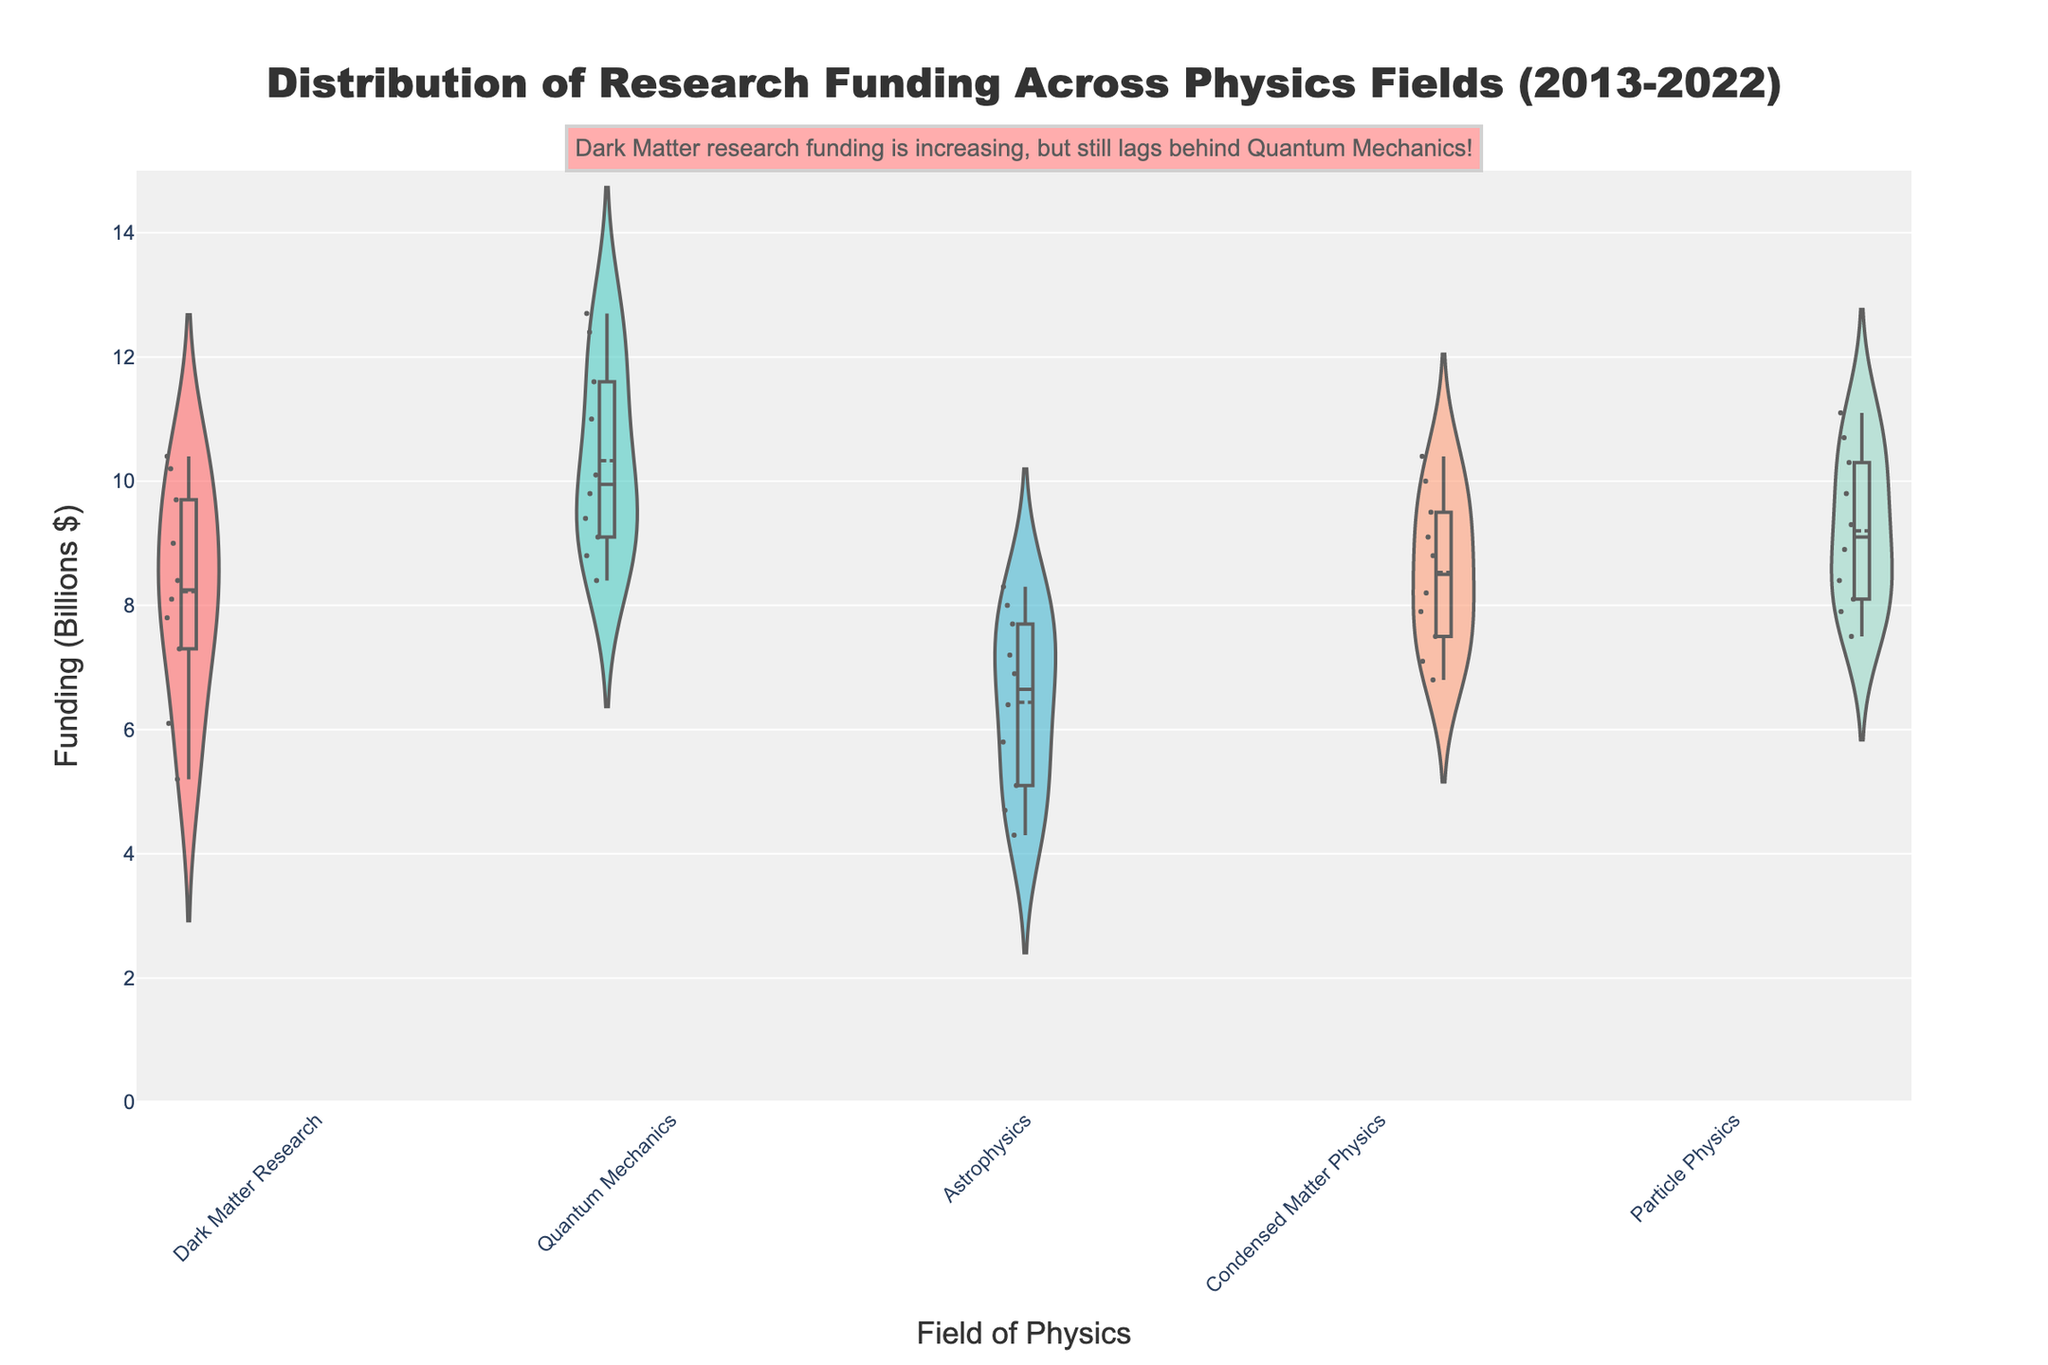What is the title of the plot? The title is located at the top of the plot, providing a summary of what the chart represents.
Answer: Distribution of Research Funding Across Physics Fields (2013-2022) Which field of physics has the highest median funding? By observing where the median line (white line in the violin plot) is highest, we identify the field with the highest median funding. Quantum Mechanics has the highest median funding.
Answer: Quantum Mechanics What is the approximate range of research funding for Dark Matter Research? Look at the spread of the violin plot for Dark Matter Research to determine the minimum and maximum funding values. The range is approximately from 5.2 to 10.4 billion dollars.
Answer: 5.2 to 10.4 billion dollars Is the research funding for Astrophysics generally increasing? Observing the pattern of the data points within the violin plot for Astrophysics can indicate if the funding values are trending upward over time. The funding for Astrophysics shows an increasing trend.
Answer: Yes What is the difference between the maximum and minimum research funding for Particle Physics? Identify the maximum and minimum funding values for Particle Physics from the violin plot and subtract the minimum from the maximum. The difference is 11.1 - 7.5 = 3.6 billion dollars.
Answer: 3.6 billion dollars Which field shows the smallest variability in research funding? The field with the narrowest spread in the violin plot has the smallest variability. Dark Matter Research has the smallest variability as it appears narrowest compared to others.
Answer: Dark Matter Research How does the median funding for Condensed Matter Physics compare to Dark Matter Research? Compare the positions of the median lines (white lines) for both fields to determine which one is higher. The median funding for Condensed Matter Physics is higher than that for Dark Matter Research.
Answer: Higher Does Particle Physics have any funding values above 11 billion dollars? Check the highest value range on the y-axis within the Particle Physics violin plot to see if it exceeds 11 billion dollars. Funding for Particle Physics does go up to 11.1 billion dollars.
Answer: Yes Which field shows the most consistent increase in funding over the decade? Look at the smoothness and upward trend of the data points within each violin plot to find the most consistent increase. Quantum Mechanics shows a very consistent and steady increase over the decade.
Answer: Quantum Mechanics How does the overall funding for Quantum Mechanics compare to Astrophysics? Compare the general spread and range of the violin plots for both fields of physics. Quantum Mechanics has a higher overall funding range compared to Astrophysics.
Answer: Higher 